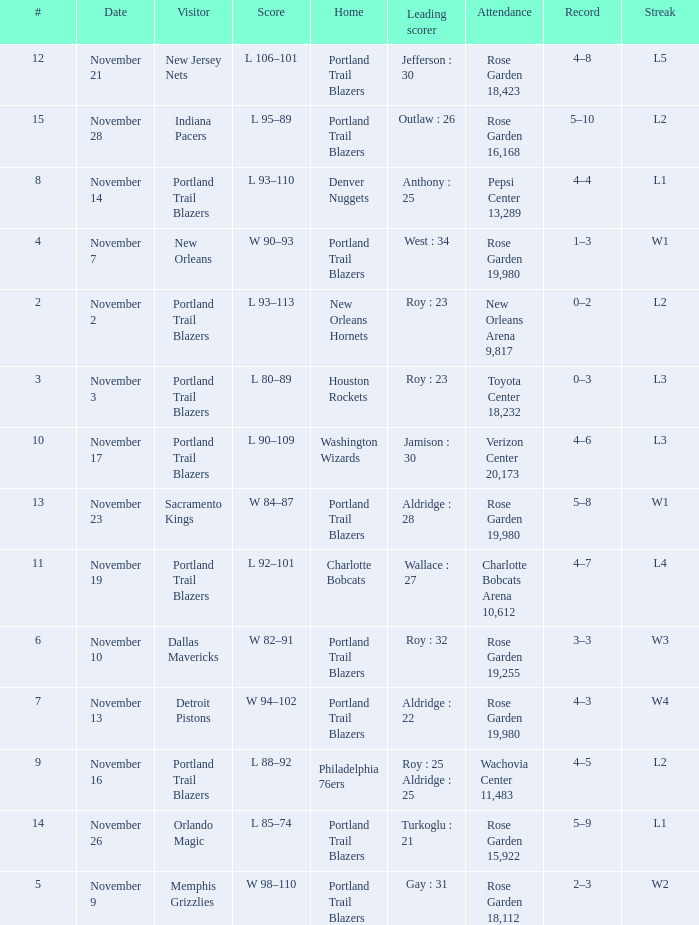 what's the attendance where score is l 92–101 Charlotte Bobcats Arena 10,612. 